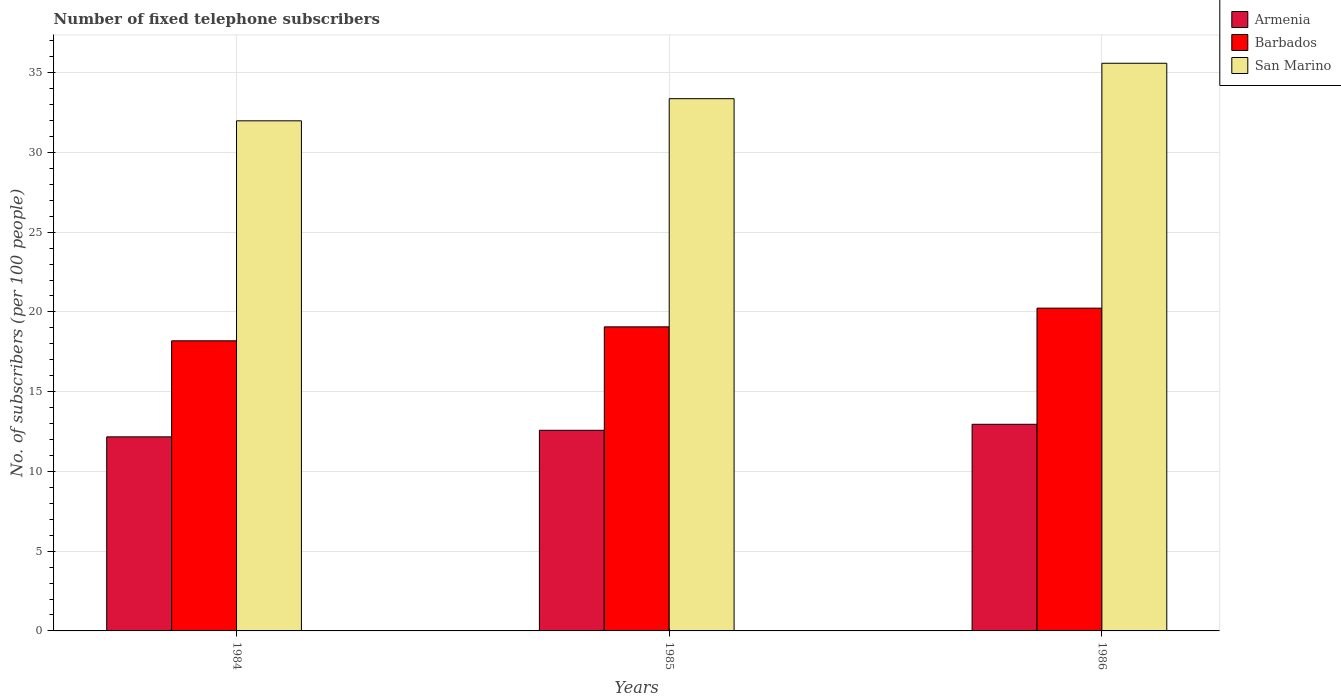How many groups of bars are there?
Make the answer very short. 3. Are the number of bars on each tick of the X-axis equal?
Keep it short and to the point. Yes. How many bars are there on the 3rd tick from the right?
Provide a succinct answer. 3. What is the label of the 3rd group of bars from the left?
Provide a short and direct response. 1986. In how many cases, is the number of bars for a given year not equal to the number of legend labels?
Your response must be concise. 0. What is the number of fixed telephone subscribers in San Marino in 1985?
Your response must be concise. 33.37. Across all years, what is the maximum number of fixed telephone subscribers in Barbados?
Provide a succinct answer. 20.24. Across all years, what is the minimum number of fixed telephone subscribers in San Marino?
Offer a terse response. 31.98. In which year was the number of fixed telephone subscribers in San Marino maximum?
Provide a succinct answer. 1986. In which year was the number of fixed telephone subscribers in Barbados minimum?
Your answer should be very brief. 1984. What is the total number of fixed telephone subscribers in Barbados in the graph?
Ensure brevity in your answer.  57.49. What is the difference between the number of fixed telephone subscribers in Barbados in 1984 and that in 1985?
Offer a terse response. -0.88. What is the difference between the number of fixed telephone subscribers in Armenia in 1986 and the number of fixed telephone subscribers in San Marino in 1984?
Ensure brevity in your answer.  -19.03. What is the average number of fixed telephone subscribers in Barbados per year?
Offer a very short reply. 19.16. In the year 1985, what is the difference between the number of fixed telephone subscribers in Barbados and number of fixed telephone subscribers in San Marino?
Provide a succinct answer. -14.31. What is the ratio of the number of fixed telephone subscribers in Armenia in 1984 to that in 1985?
Your answer should be very brief. 0.97. Is the number of fixed telephone subscribers in Barbados in 1984 less than that in 1986?
Ensure brevity in your answer.  Yes. Is the difference between the number of fixed telephone subscribers in Barbados in 1984 and 1986 greater than the difference between the number of fixed telephone subscribers in San Marino in 1984 and 1986?
Your response must be concise. Yes. What is the difference between the highest and the second highest number of fixed telephone subscribers in Armenia?
Provide a short and direct response. 0.38. What is the difference between the highest and the lowest number of fixed telephone subscribers in Armenia?
Provide a succinct answer. 0.79. In how many years, is the number of fixed telephone subscribers in San Marino greater than the average number of fixed telephone subscribers in San Marino taken over all years?
Ensure brevity in your answer.  1. What does the 2nd bar from the left in 1984 represents?
Keep it short and to the point. Barbados. What does the 3rd bar from the right in 1985 represents?
Keep it short and to the point. Armenia. How many bars are there?
Offer a very short reply. 9. Are all the bars in the graph horizontal?
Ensure brevity in your answer.  No. How many years are there in the graph?
Provide a succinct answer. 3. How many legend labels are there?
Offer a very short reply. 3. What is the title of the graph?
Provide a succinct answer. Number of fixed telephone subscribers. Does "Panama" appear as one of the legend labels in the graph?
Your answer should be compact. No. What is the label or title of the X-axis?
Your response must be concise. Years. What is the label or title of the Y-axis?
Give a very brief answer. No. of subscribers (per 100 people). What is the No. of subscribers (per 100 people) of Armenia in 1984?
Ensure brevity in your answer.  12.17. What is the No. of subscribers (per 100 people) of Barbados in 1984?
Your answer should be compact. 18.19. What is the No. of subscribers (per 100 people) of San Marino in 1984?
Provide a succinct answer. 31.98. What is the No. of subscribers (per 100 people) of Armenia in 1985?
Keep it short and to the point. 12.58. What is the No. of subscribers (per 100 people) of Barbados in 1985?
Make the answer very short. 19.06. What is the No. of subscribers (per 100 people) in San Marino in 1985?
Your answer should be very brief. 33.37. What is the No. of subscribers (per 100 people) of Armenia in 1986?
Ensure brevity in your answer.  12.95. What is the No. of subscribers (per 100 people) of Barbados in 1986?
Your answer should be very brief. 20.24. What is the No. of subscribers (per 100 people) of San Marino in 1986?
Ensure brevity in your answer.  35.59. Across all years, what is the maximum No. of subscribers (per 100 people) of Armenia?
Your answer should be very brief. 12.95. Across all years, what is the maximum No. of subscribers (per 100 people) in Barbados?
Offer a terse response. 20.24. Across all years, what is the maximum No. of subscribers (per 100 people) of San Marino?
Ensure brevity in your answer.  35.59. Across all years, what is the minimum No. of subscribers (per 100 people) in Armenia?
Your answer should be very brief. 12.17. Across all years, what is the minimum No. of subscribers (per 100 people) of Barbados?
Provide a succinct answer. 18.19. Across all years, what is the minimum No. of subscribers (per 100 people) in San Marino?
Offer a very short reply. 31.98. What is the total No. of subscribers (per 100 people) in Armenia in the graph?
Your answer should be compact. 37.7. What is the total No. of subscribers (per 100 people) of Barbados in the graph?
Provide a short and direct response. 57.49. What is the total No. of subscribers (per 100 people) in San Marino in the graph?
Give a very brief answer. 100.94. What is the difference between the No. of subscribers (per 100 people) in Armenia in 1984 and that in 1985?
Offer a terse response. -0.41. What is the difference between the No. of subscribers (per 100 people) in Barbados in 1984 and that in 1985?
Keep it short and to the point. -0.88. What is the difference between the No. of subscribers (per 100 people) in San Marino in 1984 and that in 1985?
Your answer should be compact. -1.39. What is the difference between the No. of subscribers (per 100 people) in Armenia in 1984 and that in 1986?
Offer a terse response. -0.79. What is the difference between the No. of subscribers (per 100 people) of Barbados in 1984 and that in 1986?
Provide a short and direct response. -2.05. What is the difference between the No. of subscribers (per 100 people) of San Marino in 1984 and that in 1986?
Ensure brevity in your answer.  -3.61. What is the difference between the No. of subscribers (per 100 people) in Armenia in 1985 and that in 1986?
Give a very brief answer. -0.38. What is the difference between the No. of subscribers (per 100 people) in Barbados in 1985 and that in 1986?
Your response must be concise. -1.17. What is the difference between the No. of subscribers (per 100 people) of San Marino in 1985 and that in 1986?
Offer a very short reply. -2.22. What is the difference between the No. of subscribers (per 100 people) in Armenia in 1984 and the No. of subscribers (per 100 people) in Barbados in 1985?
Your answer should be very brief. -6.9. What is the difference between the No. of subscribers (per 100 people) in Armenia in 1984 and the No. of subscribers (per 100 people) in San Marino in 1985?
Ensure brevity in your answer.  -21.2. What is the difference between the No. of subscribers (per 100 people) in Barbados in 1984 and the No. of subscribers (per 100 people) in San Marino in 1985?
Your answer should be compact. -15.18. What is the difference between the No. of subscribers (per 100 people) of Armenia in 1984 and the No. of subscribers (per 100 people) of Barbados in 1986?
Offer a terse response. -8.07. What is the difference between the No. of subscribers (per 100 people) of Armenia in 1984 and the No. of subscribers (per 100 people) of San Marino in 1986?
Keep it short and to the point. -23.42. What is the difference between the No. of subscribers (per 100 people) of Barbados in 1984 and the No. of subscribers (per 100 people) of San Marino in 1986?
Your answer should be compact. -17.4. What is the difference between the No. of subscribers (per 100 people) in Armenia in 1985 and the No. of subscribers (per 100 people) in Barbados in 1986?
Your answer should be very brief. -7.66. What is the difference between the No. of subscribers (per 100 people) in Armenia in 1985 and the No. of subscribers (per 100 people) in San Marino in 1986?
Provide a succinct answer. -23.01. What is the difference between the No. of subscribers (per 100 people) in Barbados in 1985 and the No. of subscribers (per 100 people) in San Marino in 1986?
Give a very brief answer. -16.53. What is the average No. of subscribers (per 100 people) in Armenia per year?
Your answer should be very brief. 12.57. What is the average No. of subscribers (per 100 people) in Barbados per year?
Offer a very short reply. 19.16. What is the average No. of subscribers (per 100 people) of San Marino per year?
Your answer should be very brief. 33.65. In the year 1984, what is the difference between the No. of subscribers (per 100 people) of Armenia and No. of subscribers (per 100 people) of Barbados?
Ensure brevity in your answer.  -6.02. In the year 1984, what is the difference between the No. of subscribers (per 100 people) of Armenia and No. of subscribers (per 100 people) of San Marino?
Your answer should be compact. -19.81. In the year 1984, what is the difference between the No. of subscribers (per 100 people) of Barbados and No. of subscribers (per 100 people) of San Marino?
Offer a very short reply. -13.79. In the year 1985, what is the difference between the No. of subscribers (per 100 people) of Armenia and No. of subscribers (per 100 people) of Barbados?
Provide a short and direct response. -6.49. In the year 1985, what is the difference between the No. of subscribers (per 100 people) of Armenia and No. of subscribers (per 100 people) of San Marino?
Make the answer very short. -20.79. In the year 1985, what is the difference between the No. of subscribers (per 100 people) of Barbados and No. of subscribers (per 100 people) of San Marino?
Keep it short and to the point. -14.31. In the year 1986, what is the difference between the No. of subscribers (per 100 people) of Armenia and No. of subscribers (per 100 people) of Barbados?
Offer a very short reply. -7.28. In the year 1986, what is the difference between the No. of subscribers (per 100 people) of Armenia and No. of subscribers (per 100 people) of San Marino?
Provide a short and direct response. -22.63. In the year 1986, what is the difference between the No. of subscribers (per 100 people) in Barbados and No. of subscribers (per 100 people) in San Marino?
Provide a succinct answer. -15.35. What is the ratio of the No. of subscribers (per 100 people) of Armenia in 1984 to that in 1985?
Ensure brevity in your answer.  0.97. What is the ratio of the No. of subscribers (per 100 people) in Barbados in 1984 to that in 1985?
Provide a succinct answer. 0.95. What is the ratio of the No. of subscribers (per 100 people) of San Marino in 1984 to that in 1985?
Offer a very short reply. 0.96. What is the ratio of the No. of subscribers (per 100 people) of Armenia in 1984 to that in 1986?
Provide a succinct answer. 0.94. What is the ratio of the No. of subscribers (per 100 people) of Barbados in 1984 to that in 1986?
Give a very brief answer. 0.9. What is the ratio of the No. of subscribers (per 100 people) of San Marino in 1984 to that in 1986?
Give a very brief answer. 0.9. What is the ratio of the No. of subscribers (per 100 people) of Armenia in 1985 to that in 1986?
Make the answer very short. 0.97. What is the ratio of the No. of subscribers (per 100 people) in Barbados in 1985 to that in 1986?
Provide a succinct answer. 0.94. What is the ratio of the No. of subscribers (per 100 people) in San Marino in 1985 to that in 1986?
Ensure brevity in your answer.  0.94. What is the difference between the highest and the second highest No. of subscribers (per 100 people) of Armenia?
Give a very brief answer. 0.38. What is the difference between the highest and the second highest No. of subscribers (per 100 people) of Barbados?
Provide a short and direct response. 1.17. What is the difference between the highest and the second highest No. of subscribers (per 100 people) in San Marino?
Offer a terse response. 2.22. What is the difference between the highest and the lowest No. of subscribers (per 100 people) in Armenia?
Give a very brief answer. 0.79. What is the difference between the highest and the lowest No. of subscribers (per 100 people) of Barbados?
Provide a short and direct response. 2.05. What is the difference between the highest and the lowest No. of subscribers (per 100 people) of San Marino?
Your answer should be compact. 3.61. 